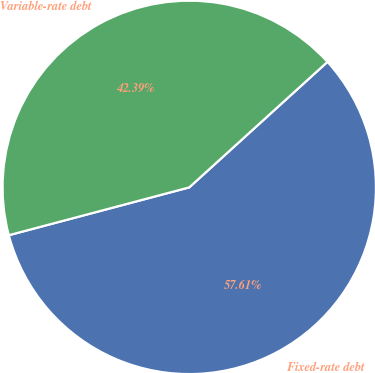Convert chart to OTSL. <chart><loc_0><loc_0><loc_500><loc_500><pie_chart><fcel>Fixed-rate debt<fcel>Variable-rate debt<nl><fcel>57.61%<fcel>42.39%<nl></chart> 